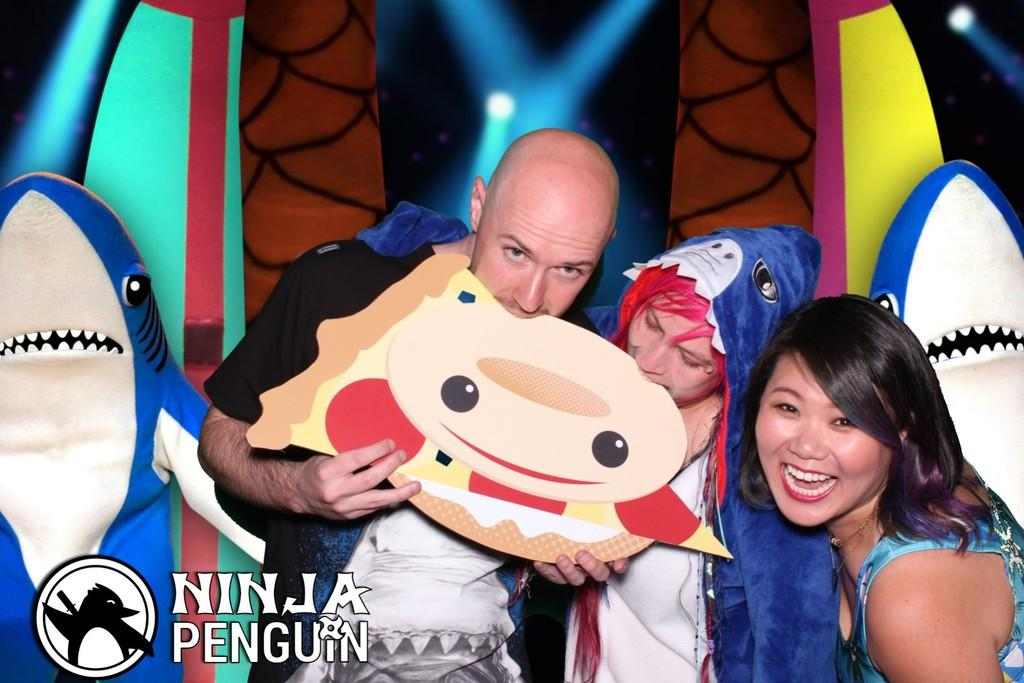How many people are in the image? There are three persons standing in the center of the image. What is the surface on which the persons are standing? The persons are standing on the floor. What can be seen in the background of the image? There are toys and decors in the background of the image. Where is the text located in the image? The text is at the bottom left corner of the image. What type of tools is the carpenter using in the image? There is no carpenter present in the image, and therefore no tools can be observed. How many snakes are slithering around the persons in the image? There are no snakes present in the image; the persons are standing with no animals around them. 